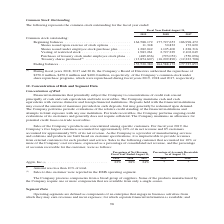From Jabil Circuit's financial document, What years does the table provide information for the common stock outstanding for? The document contains multiple relevant values: 2019, 2018, 2017. From the document: "2019 2018 2017 2019 2018 2017 2019 2018 2017..." Also, What was the Beginning balance in 2019? According to the financial document, 164,588,172. The relevant text states: "Common stock outstanding: Beginning balances . 164,588,172 177,727,653 186,998,472 Shares issued upon exercise of stock options . 11,348 30,832 172,620 Shares..." Also, What was the Ending balance in 2017? According to the financial document, 177,727,653. The relevant text states: "ock outstanding: Beginning balances . 164,588,172 177,727,653 186,998,472 Shares issued upon exercise of stock options . 11,348 30,832 172,620 Shares issued unde..." Also, can you calculate: What was the change in the Vesting of restricted stock between 2018 and 2019? Based on the calculation: 1,983,261-2,727,229, the result is -743968. This is based on the information: "1,228,316 Vesting of restricted stock . 1,983,261 2,727,229 2,102,049 Purchases of treasury stock under employee stock plans . (489,836) (793,052) (550,096) Tr 1,105,400 1,228,316 Vesting of restricte..." The key data points involved are: 1,983,261, 2,727,229. Also, How many years did the Shares issued upon exercise of stock options exceed 100,000? Based on the analysis, there are 1 instances. The counting process: 2017. Also, can you calculate: What was the percentage change in the ending balance between 2018 and 2019? To answer this question, I need to perform calculations using the financial data. The calculation is: (153,520,380-164,588,172)/164,588,172, which equals -6.72 (percentage). This is based on the information: "Ending balances . 153,520,380 164,588,172 177,727,653 Ending balances . 153,520,380 164,588,172 177,727,653..." The key data points involved are: 153,520,380, 164,588,172. 